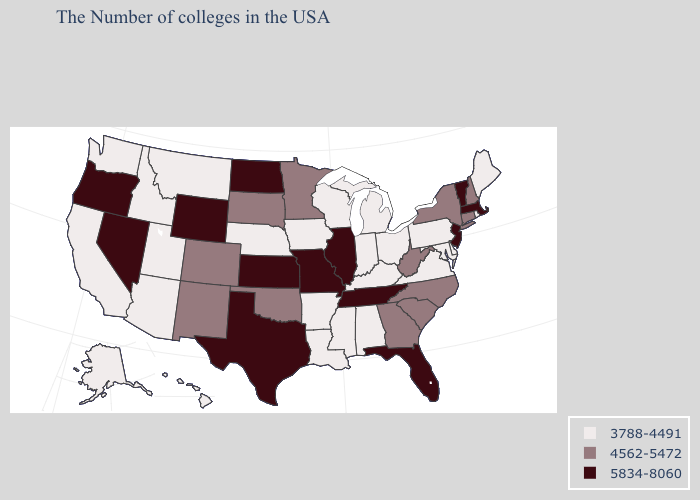What is the value of Wisconsin?
Keep it brief. 3788-4491. Name the states that have a value in the range 4562-5472?
Concise answer only. New Hampshire, Connecticut, New York, North Carolina, South Carolina, West Virginia, Georgia, Minnesota, Oklahoma, South Dakota, Colorado, New Mexico. Among the states that border California , does Oregon have the highest value?
Concise answer only. Yes. What is the value of Utah?
Be succinct. 3788-4491. What is the value of New York?
Short answer required. 4562-5472. What is the value of Pennsylvania?
Give a very brief answer. 3788-4491. How many symbols are there in the legend?
Be succinct. 3. Which states have the lowest value in the USA?
Quick response, please. Maine, Rhode Island, Delaware, Maryland, Pennsylvania, Virginia, Ohio, Michigan, Kentucky, Indiana, Alabama, Wisconsin, Mississippi, Louisiana, Arkansas, Iowa, Nebraska, Utah, Montana, Arizona, Idaho, California, Washington, Alaska, Hawaii. Does Missouri have the highest value in the USA?
Write a very short answer. Yes. Does Connecticut have a higher value than Rhode Island?
Short answer required. Yes. Name the states that have a value in the range 5834-8060?
Concise answer only. Massachusetts, Vermont, New Jersey, Florida, Tennessee, Illinois, Missouri, Kansas, Texas, North Dakota, Wyoming, Nevada, Oregon. Does Oregon have the same value as North Dakota?
Be succinct. Yes. Which states hav the highest value in the Northeast?
Give a very brief answer. Massachusetts, Vermont, New Jersey. Does West Virginia have the same value as New York?
Write a very short answer. Yes. Does Arkansas have the highest value in the USA?
Answer briefly. No. 